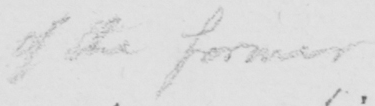What text is written in this handwritten line? of the former 